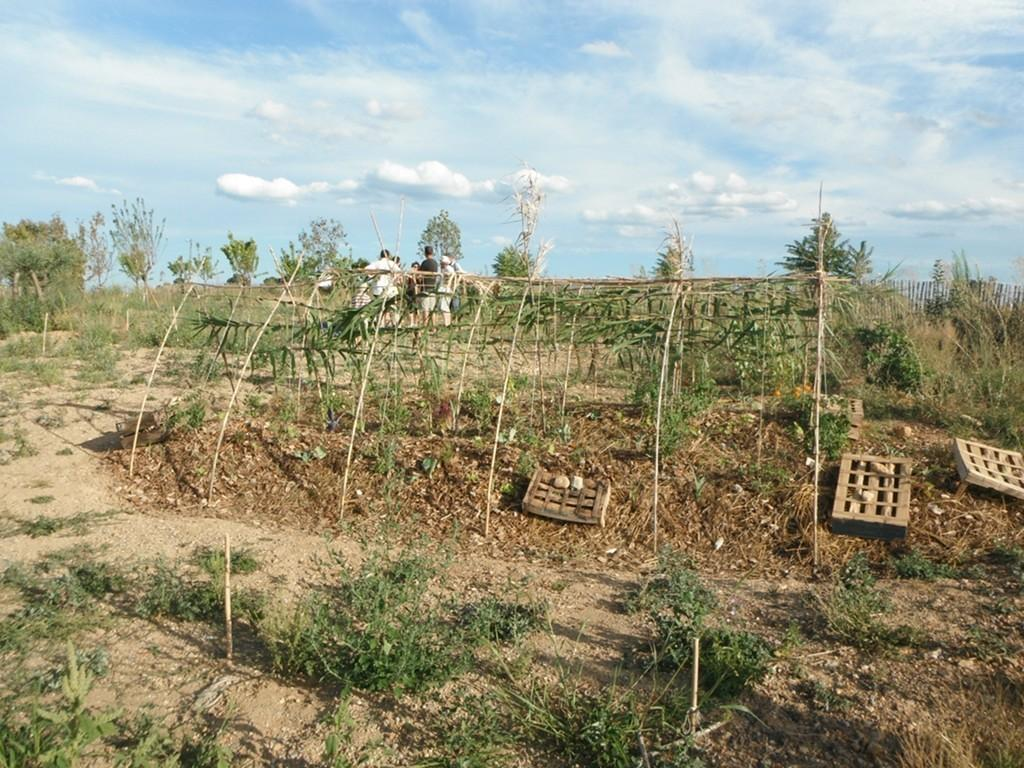What type of vegetation can be seen in the image? There are trees and plants in the image. What else can be seen on the ground in the image? There are sticks and a group of people standing on the ground in the image. What is visible at the top of the image? The sky is visible at the top of the image. How would you describe the sky in the image? The sky appears to be cloudy in the image. What type of key is being used to unlock the family's hope in the image? There is no mention of a key, family, or hope in the image; it features trees, plants, sticks, a group of people, and a cloudy sky. 